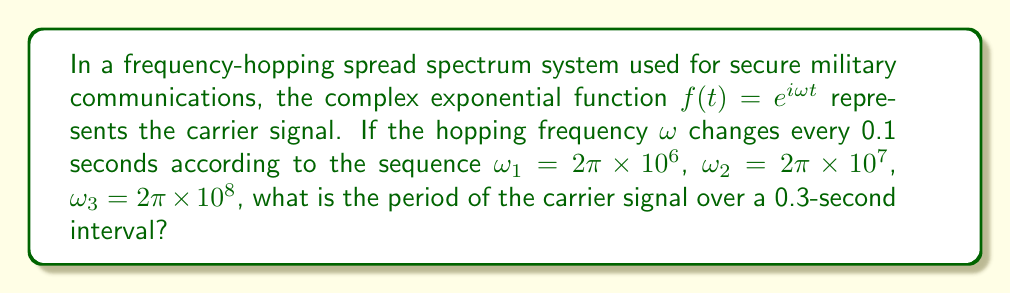What is the answer to this math problem? To solve this problem, we need to analyze the periodicity of the complex exponential function for each frequency:

1. For a complex exponential function $f(t) = e^{i\omega t}$, the period $T$ is given by:
   $$T = \frac{2\pi}{\omega}$$

2. Calculate the period for each frequency:
   a) For $\omega_1 = 2\pi \times 10^6$:
      $$T_1 = \frac{2\pi}{2\pi \times 10^6} = 10^{-6} \text{ seconds}$$
   
   b) For $\omega_2 = 2\pi \times 10^7$:
      $$T_2 = \frac{2\pi}{2\pi \times 10^7} = 10^{-7} \text{ seconds}$$
   
   c) For $\omega_3 = 2\pi \times 10^8$:
      $$T_3 = \frac{2\pi}{2\pi \times 10^8} = 10^{-8} \text{ seconds}$$

3. Each frequency is used for 0.1 seconds, which is much longer than its period. This means the signal completes multiple cycles for each frequency.

4. The overall period of the carrier signal over the 0.3-second interval is the least common multiple (LCM) of the three periods, as this is when the signal would repeat its entire pattern.

5. However, since the frequency-hopping occurs at fixed 0.1-second intervals, which is much larger than any of the individual periods, the signal never actually completes a full cycle of the combined pattern.

6. Therefore, the period of the carrier signal over the 0.3-second interval is simply 0.3 seconds, as this is when the entire frequency-hopping sequence repeats.
Answer: 0.3 seconds 